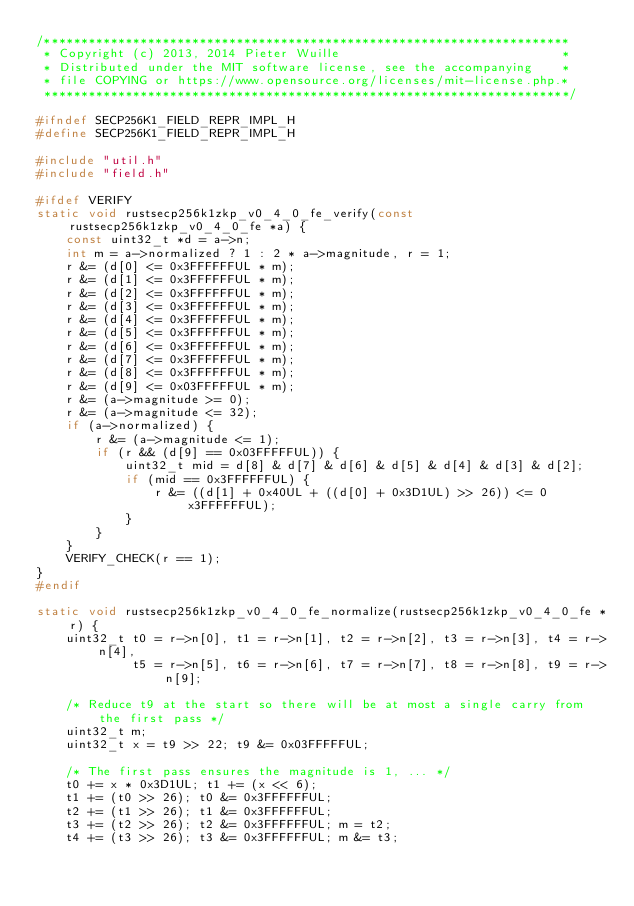<code> <loc_0><loc_0><loc_500><loc_500><_C_>/***********************************************************************
 * Copyright (c) 2013, 2014 Pieter Wuille                              *
 * Distributed under the MIT software license, see the accompanying    *
 * file COPYING or https://www.opensource.org/licenses/mit-license.php.*
 ***********************************************************************/

#ifndef SECP256K1_FIELD_REPR_IMPL_H
#define SECP256K1_FIELD_REPR_IMPL_H

#include "util.h"
#include "field.h"

#ifdef VERIFY
static void rustsecp256k1zkp_v0_4_0_fe_verify(const rustsecp256k1zkp_v0_4_0_fe *a) {
    const uint32_t *d = a->n;
    int m = a->normalized ? 1 : 2 * a->magnitude, r = 1;
    r &= (d[0] <= 0x3FFFFFFUL * m);
    r &= (d[1] <= 0x3FFFFFFUL * m);
    r &= (d[2] <= 0x3FFFFFFUL * m);
    r &= (d[3] <= 0x3FFFFFFUL * m);
    r &= (d[4] <= 0x3FFFFFFUL * m);
    r &= (d[5] <= 0x3FFFFFFUL * m);
    r &= (d[6] <= 0x3FFFFFFUL * m);
    r &= (d[7] <= 0x3FFFFFFUL * m);
    r &= (d[8] <= 0x3FFFFFFUL * m);
    r &= (d[9] <= 0x03FFFFFUL * m);
    r &= (a->magnitude >= 0);
    r &= (a->magnitude <= 32);
    if (a->normalized) {
        r &= (a->magnitude <= 1);
        if (r && (d[9] == 0x03FFFFFUL)) {
            uint32_t mid = d[8] & d[7] & d[6] & d[5] & d[4] & d[3] & d[2];
            if (mid == 0x3FFFFFFUL) {
                r &= ((d[1] + 0x40UL + ((d[0] + 0x3D1UL) >> 26)) <= 0x3FFFFFFUL);
            }
        }
    }
    VERIFY_CHECK(r == 1);
}
#endif

static void rustsecp256k1zkp_v0_4_0_fe_normalize(rustsecp256k1zkp_v0_4_0_fe *r) {
    uint32_t t0 = r->n[0], t1 = r->n[1], t2 = r->n[2], t3 = r->n[3], t4 = r->n[4],
             t5 = r->n[5], t6 = r->n[6], t7 = r->n[7], t8 = r->n[8], t9 = r->n[9];

    /* Reduce t9 at the start so there will be at most a single carry from the first pass */
    uint32_t m;
    uint32_t x = t9 >> 22; t9 &= 0x03FFFFFUL;

    /* The first pass ensures the magnitude is 1, ... */
    t0 += x * 0x3D1UL; t1 += (x << 6);
    t1 += (t0 >> 26); t0 &= 0x3FFFFFFUL;
    t2 += (t1 >> 26); t1 &= 0x3FFFFFFUL;
    t3 += (t2 >> 26); t2 &= 0x3FFFFFFUL; m = t2;
    t4 += (t3 >> 26); t3 &= 0x3FFFFFFUL; m &= t3;</code> 